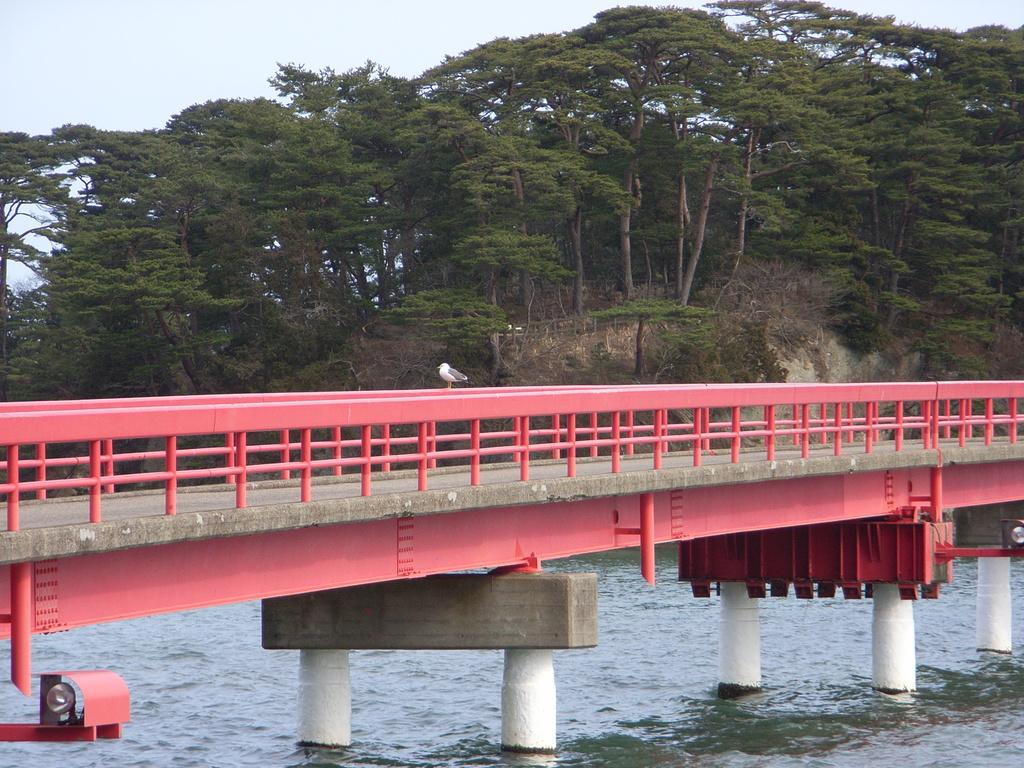What structure can be seen in the image? There is a bridge in the image. What is located on the bridge? A bird is present on the bridge. What can be seen below the bridge? There is water visible below the bridge. What type of vegetation is in the background of the image? There are trees in the background of the image. What type of insurance does the bird on the bridge have? There is no information about the bird's insurance in the image. Can you see any zebras or horses in the image? No, there are no zebras or horses present in the image. 